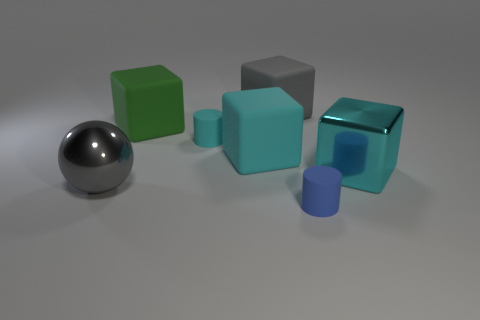What size is the gray cube that is made of the same material as the tiny cyan object?
Your answer should be very brief. Large. What is the color of the other tiny cylinder that is the same material as the small blue cylinder?
Your answer should be compact. Cyan. Is there a rubber cylinder of the same size as the green matte thing?
Provide a succinct answer. No. There is another object that is the same shape as the tiny blue object; what is its material?
Make the answer very short. Rubber. There is a cyan matte object that is the same size as the green rubber object; what shape is it?
Ensure brevity in your answer.  Cube. Is there a small gray metallic thing of the same shape as the green thing?
Offer a terse response. No. There is a large gray object on the left side of the tiny cylinder that is to the left of the small blue matte object; what shape is it?
Make the answer very short. Sphere. What is the shape of the large green thing?
Your answer should be very brief. Cube. There is a cube that is on the left side of the cylinder to the left of the cyan block that is left of the big cyan shiny object; what is it made of?
Your answer should be very brief. Rubber. How many other objects are the same material as the large ball?
Your answer should be compact. 1. 